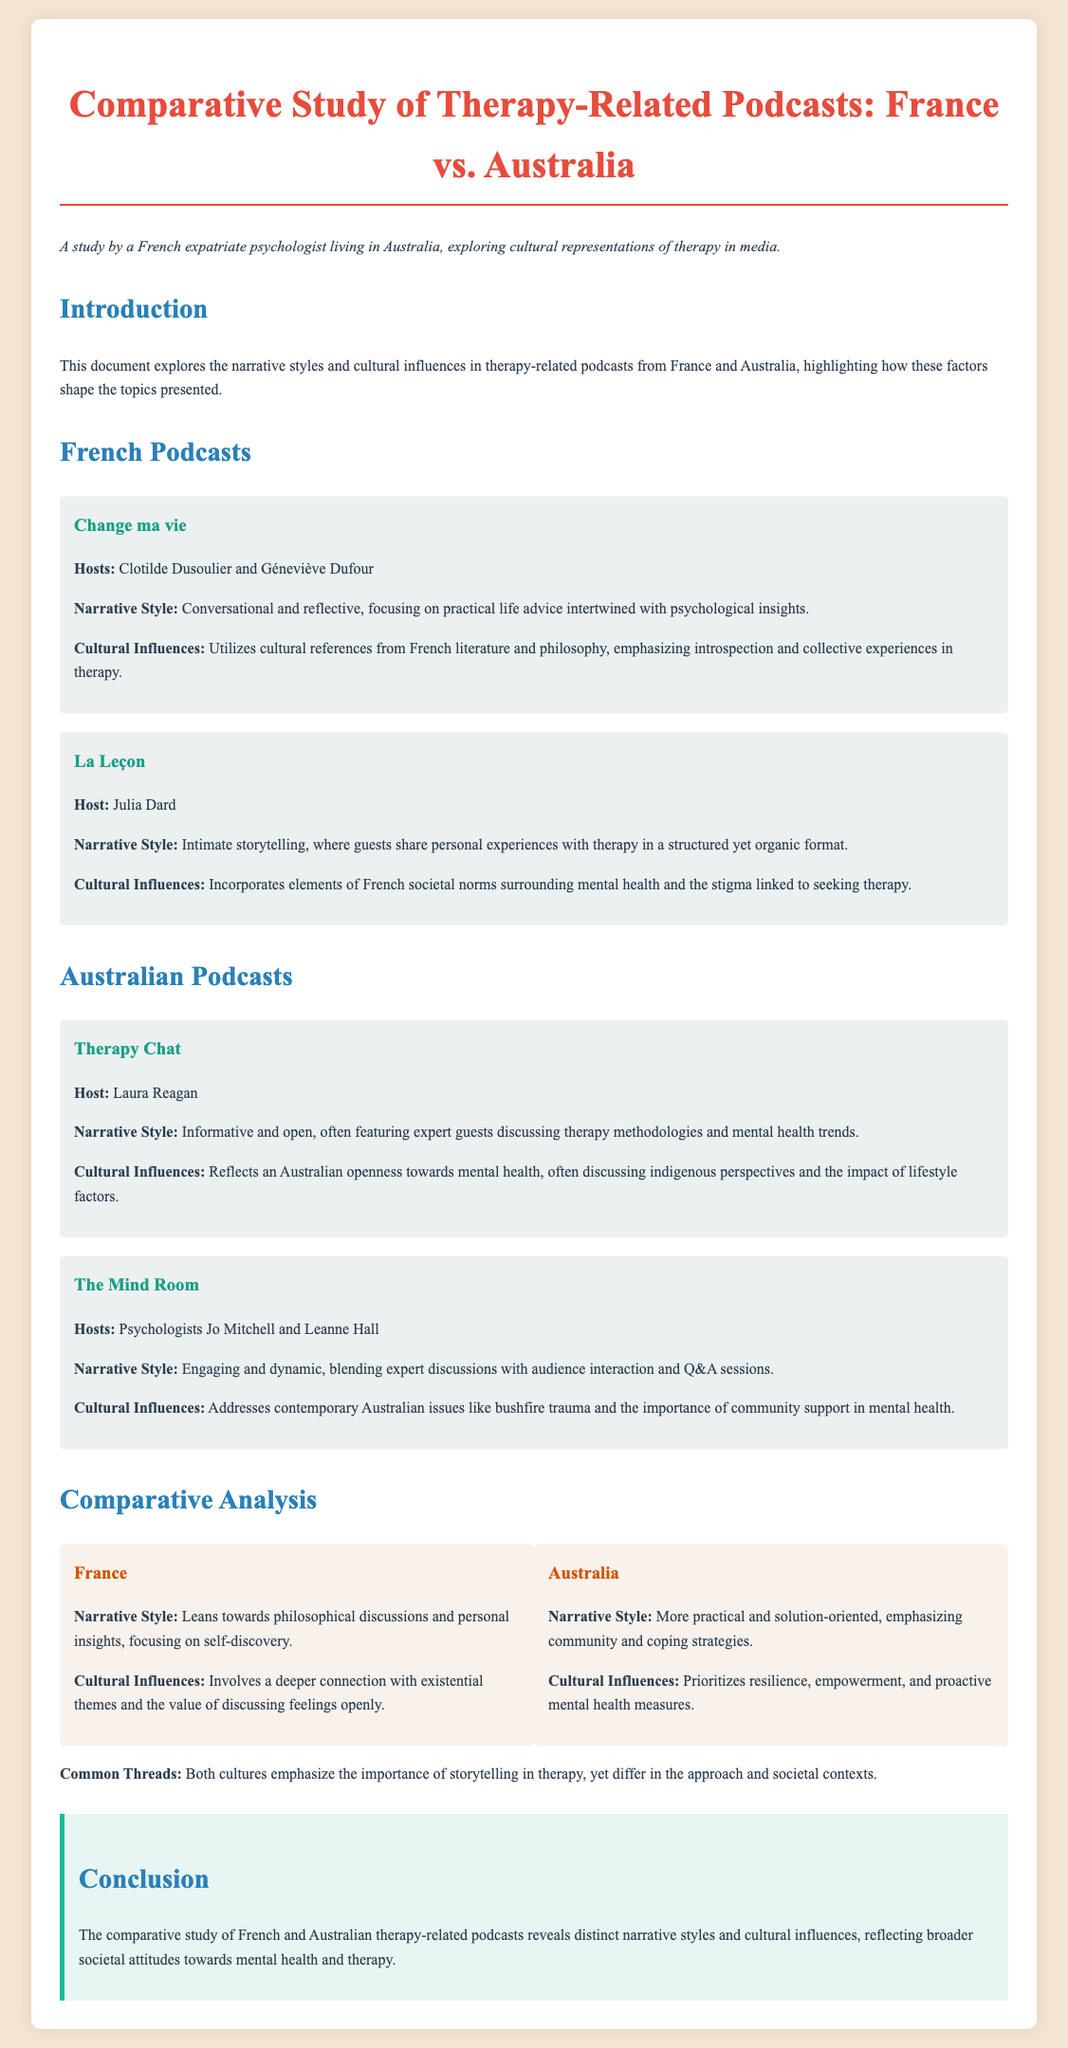What are the hosts of "Change ma vie"? The document lists Clotilde Dusoulier and Géneviève Dufour as the hosts of "Change ma vie."
Answer: Clotilde Dusoulier and Géneviève Dufour What narrative style is associated with "La Leçon"? The document describes the narrative style of "La Leçon" as intimate storytelling.
Answer: Intimate storytelling Which podcast discusses indigenous perspectives? The document states that "Therapy Chat" reflects an openness towards mental health and discusses indigenous perspectives.
Answer: Therapy Chat What cultural influences are mentioned for Australian podcasts? The document highlights that Australian podcasts often discuss contemporary issues like bushfire trauma and emphasize community support.
Answer: Contemporary issues like bushfire trauma and community support How does the narrative style of French podcasts compare to Australian ones? The document notes that French podcasts lean towards philosophical discussions while Australian ones are more practical and solution-oriented.
Answer: Philosophical discussions; practical and solution-oriented What common thread do both cultures emphasize in therapy? The document mentions that both cultures emphasize the importance of storytelling in therapy.
Answer: Importance of storytelling What is the primary focus of French therapy-related podcasts? The document states that the primary focus is on introspection and collective experiences in therapy.
Answer: Introspection and collective experiences Who are the hosts of "The Mind Room"? The document identifies Jo Mitchell and Leanne Hall as the hosts of "The Mind Room."
Answer: Jo Mitchell and Leanne Hall 